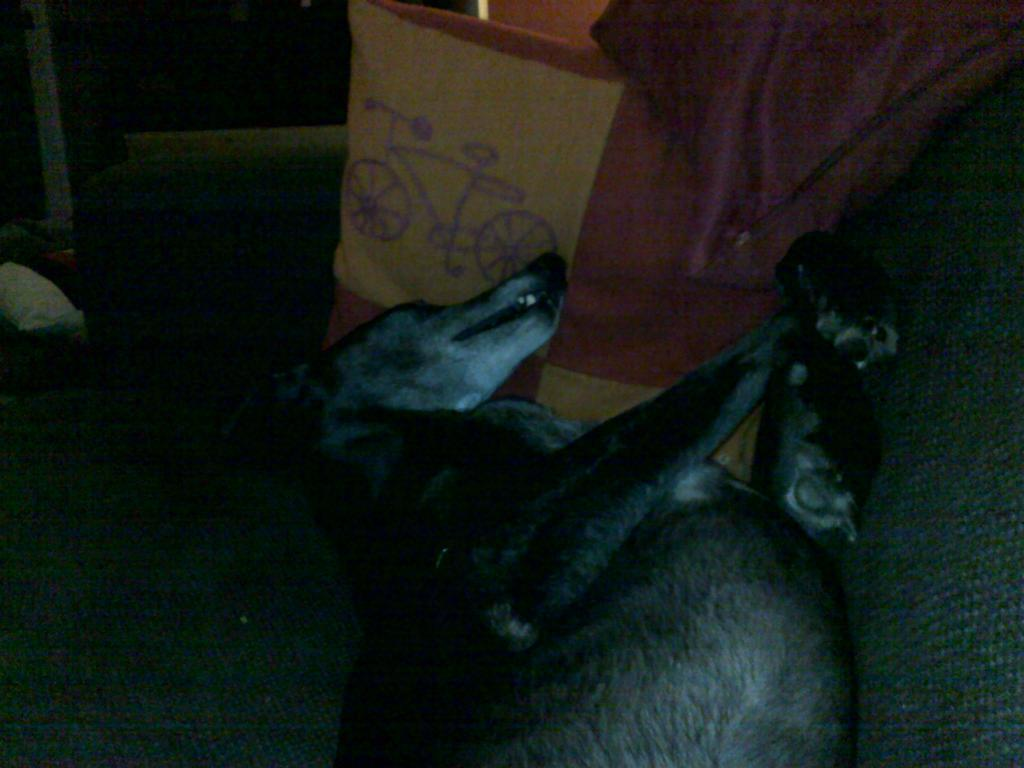What animal is present in the image? There is a dog in the image. What position is the dog in? The dog is laying on its back. What object is located beside the dog? There is a cover beside the dog. What type of page can be seen in the image? There is no page present in the image; it features a dog laying on its back with a cover beside it. How many cows are visible in the image? There are no cows present in the image. 